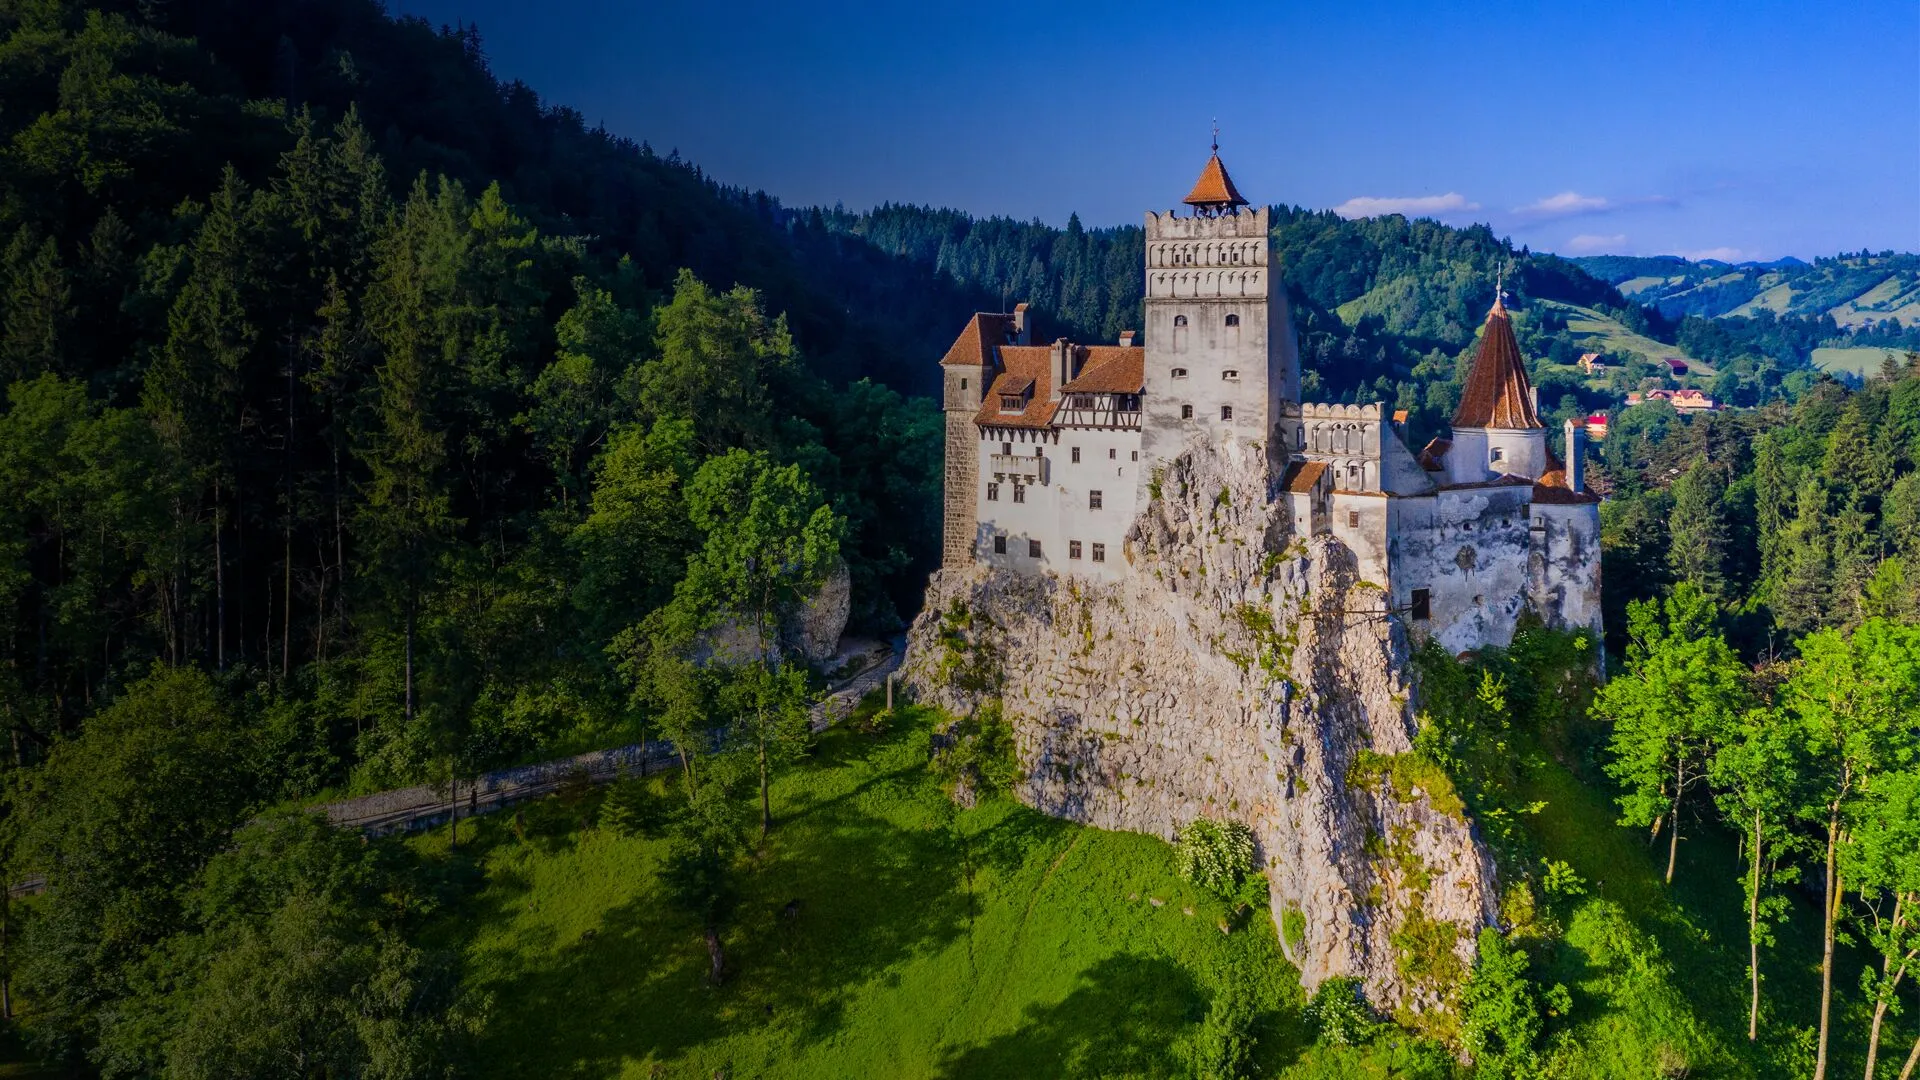What aspects of the castle's architecture are most notable? The most notable aspects of Bran Castle's architecture include its tall central tower, multiple turrets, and the distinct orange-tiled roof that stands out against the white walls. The castle's design is an amalgamation of Gothic and Renaissance styles, with arched windows, stone walls, and wooden beams that lend it a timeless, historic charm. The intricate details and imposing structure reflect its medieval origins and strategic importance. How does the surrounding environment enhance the castle's grandeur? The surrounding environment plays a crucial role in enhancing the grandeur of Bran Castle. The dense, verdant forests create a striking contrast with the bright, orange-tiled roof and stark white walls of the castle, making it visually stand out. The rocky cliff on which the castle is perched adds a sense of drama and strategic advantage, historically important for defense. The expansive views of the green valleys and distant mountains contribute to a sense of serenity and majesty, emphasizing the castle's dominance over the landscape and its prominent place in history. 